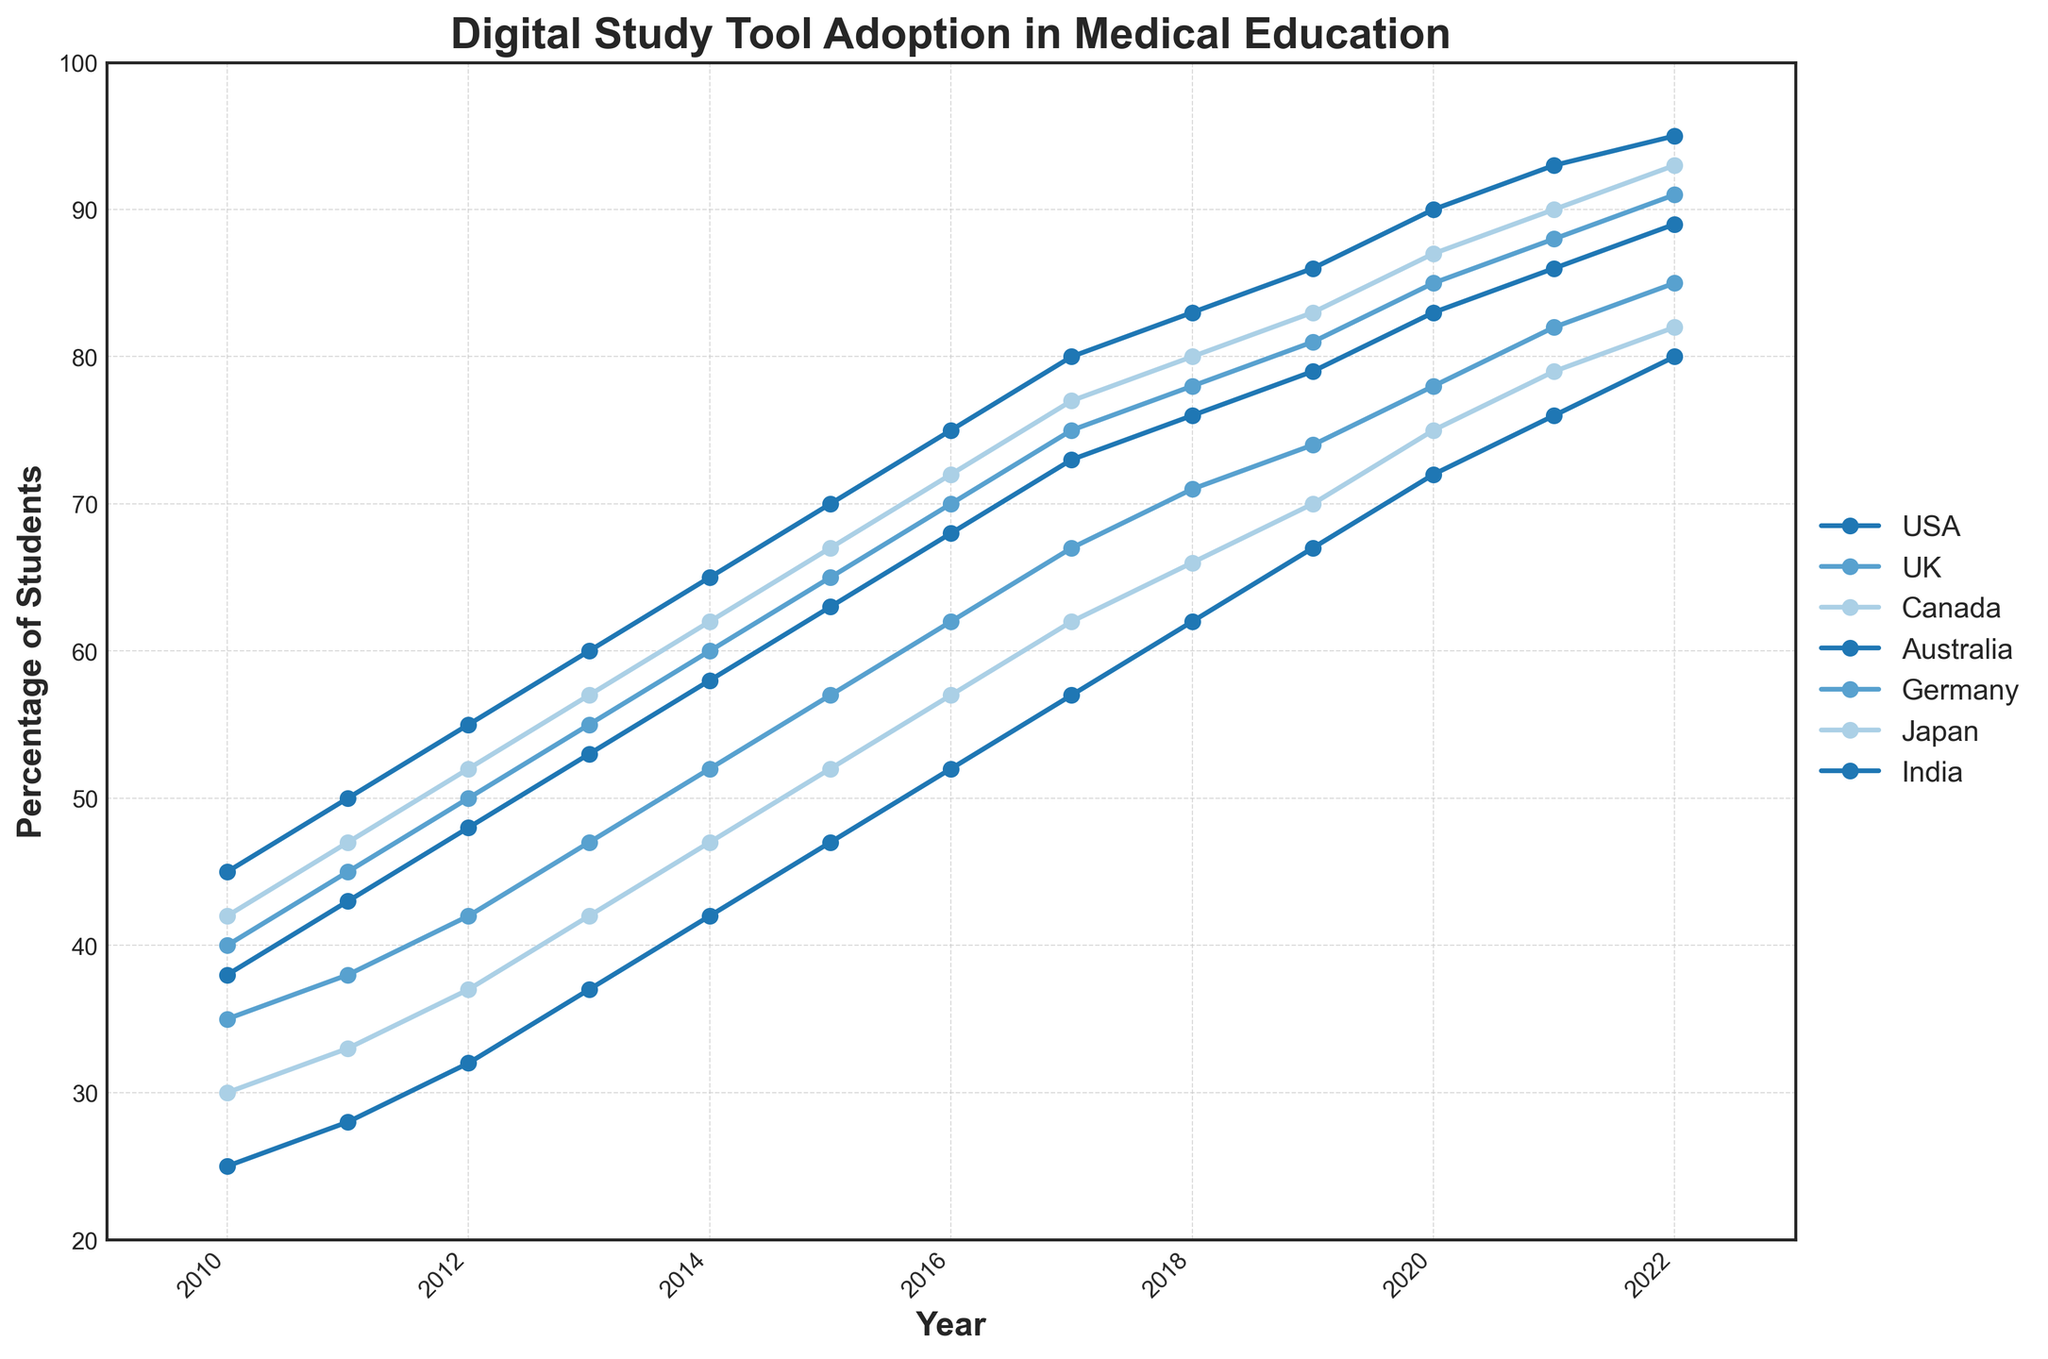What's the overall trend in the percentage of medical students using digital study tools from 2010 to 2022? From 2010 to 2022, the percentage of medical students using digital study tools in all countries shown in the figure consistently increased each year, indicating a strong upward trend in digital tool adoption.
Answer: Upward trend Which country reached a 90% usage rate of digital study tools first? By examining the lines in the figure, we can see that the USA first reached a 90% usage rate in 2020, followed by other countries in subsequent years.
Answer: USA Which country showed the most significant increase in digital study tool adoption between 2011 and 2013? To determine this, we need to calculate the increase for each country:
USA: (60-45) = 15
UK: (55-45) = 10
Canada: (57-47) = 10
Australia: (53-43) = 10
Germany: (47-38) = 9
Japan: (42-33) = 9
India: (37-28) = 9.
The USA showed the most significant increase of 15 percentage points.
Answer: USA What was the average percentage of medical students using digital study tools in 2018 for Germany and Japan? The percentages for Germany and Japan in 2018 are 71% and 66%, respectively. The average is (71 + 66) / 2 = 68.5%.
Answer: 68.5% Which country had the smallest gap in the percentage of students using digital study tools between 2010 and 2022? To find this, we compute the gap for each country from 2010 to 2022:
USA: 95 - 45 = 50
UK: 91 - 40 = 51
Canada: 93 - 42 = 51
Australia: 89 - 38 = 51
Germany: 85 - 35 = 50
Japan: 82 - 30 = 52
India: 80 - 25 = 55.
The USA and Germany both had the smallest gap of 50 percentage points.
Answer: USA and Germany At what year did the percentage of students using digital study tools in India exceed 50%? By observing the line representing India, we see that it first exceeds the 50% mark in 2016.
Answer: 2016 Among the countries shown, which one had the lowest percentage of medical students using digital study tools in 2021? By looking at the lines for 2021, Japan had the lowest percentage at 79%.
Answer: Japan In which year did Australia surpass 70% usage of digital study tools? By following the line representing Australia, it is shown that usage first surpasses 70% in 2017.
Answer: 2017 